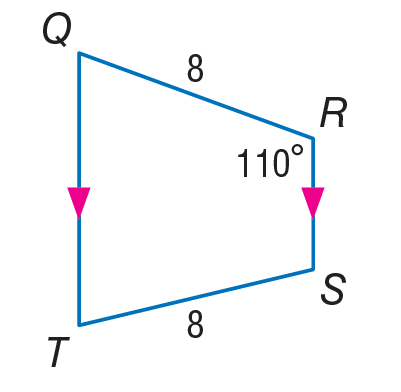Question: Find m \angle Q.
Choices:
A. 70
B. 90
C. 110
D. 180
Answer with the letter. Answer: A 